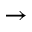Convert formula to latex. <formula><loc_0><loc_0><loc_500><loc_500>\rightarrow</formula> 